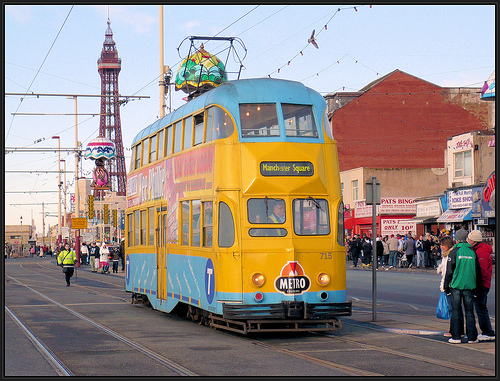<image>
Is the bus behind the man? No. The bus is not behind the man. From this viewpoint, the bus appears to be positioned elsewhere in the scene. Where is the metro in relation to the man? Is it next to the man? No. The metro is not positioned next to the man. They are located in different areas of the scene. 